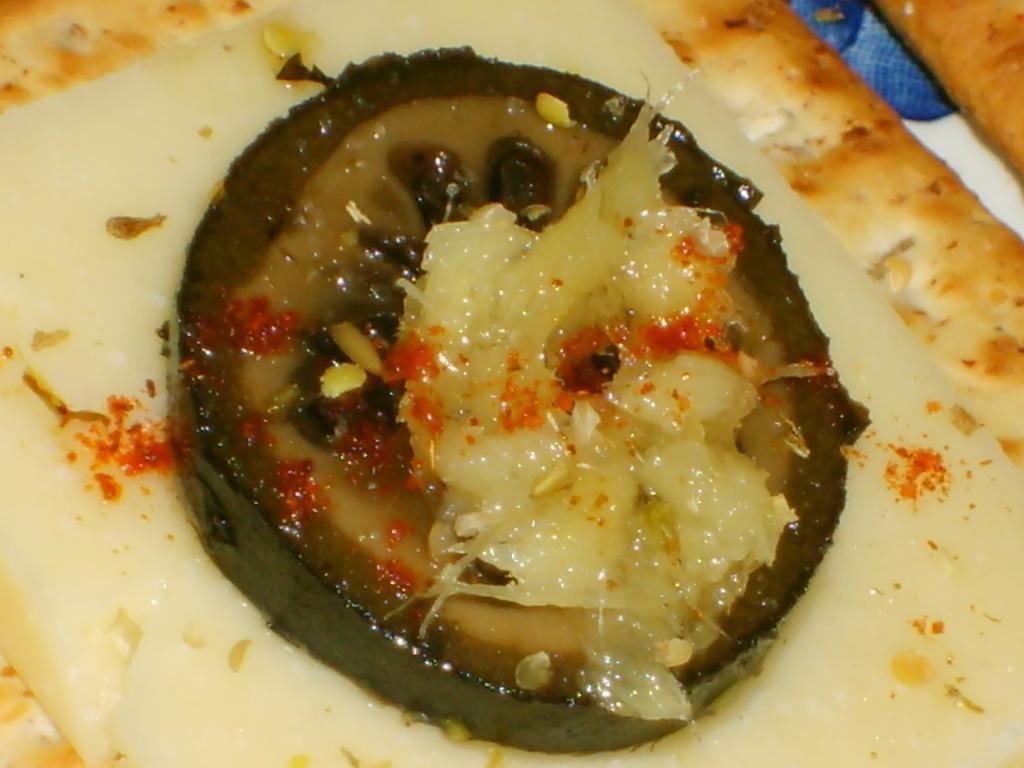How would you summarize this image in a sentence or two? In this image, we can see there is a food item. On this food item, there are some ingredients. 